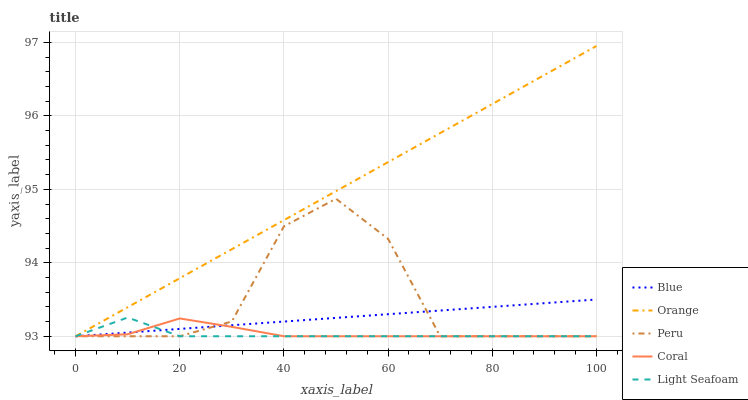Does Coral have the minimum area under the curve?
Answer yes or no. No. Does Coral have the maximum area under the curve?
Answer yes or no. No. Is Orange the smoothest?
Answer yes or no. No. Is Orange the roughest?
Answer yes or no. No. Does Coral have the highest value?
Answer yes or no. No. 